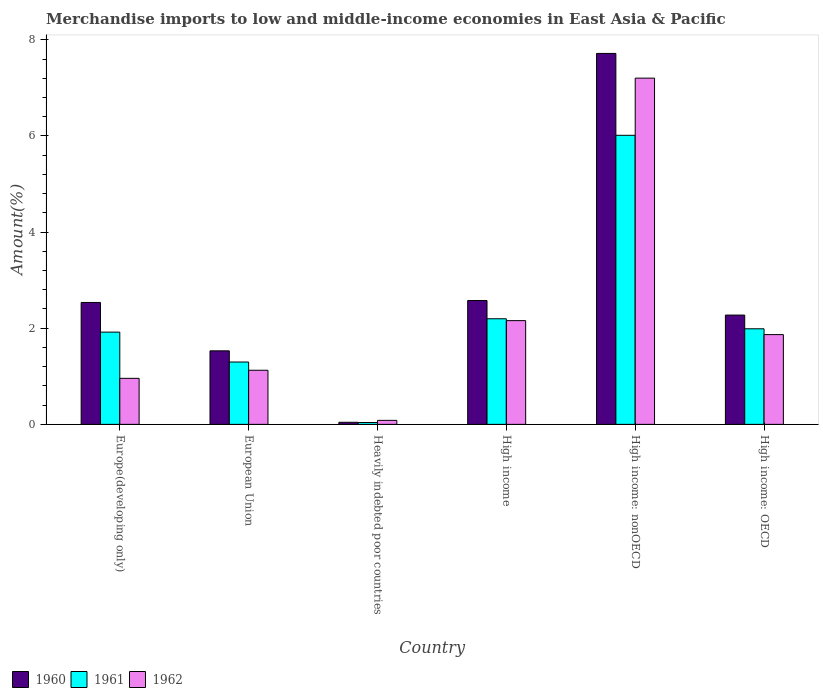How many groups of bars are there?
Keep it short and to the point. 6. Are the number of bars on each tick of the X-axis equal?
Offer a terse response. Yes. How many bars are there on the 6th tick from the right?
Your answer should be compact. 3. What is the label of the 1st group of bars from the left?
Ensure brevity in your answer.  Europe(developing only). In how many cases, is the number of bars for a given country not equal to the number of legend labels?
Your answer should be very brief. 0. What is the percentage of amount earned from merchandise imports in 1961 in Heavily indebted poor countries?
Your answer should be very brief. 0.04. Across all countries, what is the maximum percentage of amount earned from merchandise imports in 1960?
Keep it short and to the point. 7.72. Across all countries, what is the minimum percentage of amount earned from merchandise imports in 1961?
Ensure brevity in your answer.  0.04. In which country was the percentage of amount earned from merchandise imports in 1962 maximum?
Your answer should be compact. High income: nonOECD. In which country was the percentage of amount earned from merchandise imports in 1962 minimum?
Give a very brief answer. Heavily indebted poor countries. What is the total percentage of amount earned from merchandise imports in 1961 in the graph?
Provide a succinct answer. 13.45. What is the difference between the percentage of amount earned from merchandise imports in 1961 in Heavily indebted poor countries and that in High income?
Provide a short and direct response. -2.16. What is the difference between the percentage of amount earned from merchandise imports in 1962 in High income and the percentage of amount earned from merchandise imports in 1961 in High income: OECD?
Make the answer very short. 0.17. What is the average percentage of amount earned from merchandise imports in 1962 per country?
Keep it short and to the point. 2.23. What is the difference between the percentage of amount earned from merchandise imports of/in 1961 and percentage of amount earned from merchandise imports of/in 1960 in European Union?
Provide a short and direct response. -0.23. What is the ratio of the percentage of amount earned from merchandise imports in 1960 in European Union to that in High income: OECD?
Provide a succinct answer. 0.67. What is the difference between the highest and the second highest percentage of amount earned from merchandise imports in 1960?
Your answer should be very brief. 0.04. What is the difference between the highest and the lowest percentage of amount earned from merchandise imports in 1960?
Offer a very short reply. 7.67. Is the sum of the percentage of amount earned from merchandise imports in 1961 in Europe(developing only) and High income: OECD greater than the maximum percentage of amount earned from merchandise imports in 1962 across all countries?
Provide a succinct answer. No. What does the 2nd bar from the left in High income: nonOECD represents?
Give a very brief answer. 1961. What does the 2nd bar from the right in European Union represents?
Provide a short and direct response. 1961. Where does the legend appear in the graph?
Ensure brevity in your answer.  Bottom left. How many legend labels are there?
Provide a short and direct response. 3. What is the title of the graph?
Ensure brevity in your answer.  Merchandise imports to low and middle-income economies in East Asia & Pacific. What is the label or title of the X-axis?
Keep it short and to the point. Country. What is the label or title of the Y-axis?
Offer a very short reply. Amount(%). What is the Amount(%) of 1960 in Europe(developing only)?
Keep it short and to the point. 2.54. What is the Amount(%) of 1961 in Europe(developing only)?
Offer a terse response. 1.92. What is the Amount(%) of 1962 in Europe(developing only)?
Offer a terse response. 0.96. What is the Amount(%) in 1960 in European Union?
Ensure brevity in your answer.  1.53. What is the Amount(%) in 1961 in European Union?
Ensure brevity in your answer.  1.3. What is the Amount(%) of 1962 in European Union?
Make the answer very short. 1.13. What is the Amount(%) in 1960 in Heavily indebted poor countries?
Keep it short and to the point. 0.04. What is the Amount(%) in 1961 in Heavily indebted poor countries?
Provide a succinct answer. 0.04. What is the Amount(%) in 1962 in Heavily indebted poor countries?
Give a very brief answer. 0.08. What is the Amount(%) of 1960 in High income?
Make the answer very short. 2.58. What is the Amount(%) in 1961 in High income?
Give a very brief answer. 2.2. What is the Amount(%) of 1962 in High income?
Offer a terse response. 2.16. What is the Amount(%) of 1960 in High income: nonOECD?
Your response must be concise. 7.72. What is the Amount(%) of 1961 in High income: nonOECD?
Provide a succinct answer. 6.01. What is the Amount(%) of 1962 in High income: nonOECD?
Provide a short and direct response. 7.2. What is the Amount(%) in 1960 in High income: OECD?
Provide a short and direct response. 2.27. What is the Amount(%) in 1961 in High income: OECD?
Provide a succinct answer. 1.99. What is the Amount(%) in 1962 in High income: OECD?
Give a very brief answer. 1.87. Across all countries, what is the maximum Amount(%) in 1960?
Your answer should be very brief. 7.72. Across all countries, what is the maximum Amount(%) of 1961?
Ensure brevity in your answer.  6.01. Across all countries, what is the maximum Amount(%) in 1962?
Your response must be concise. 7.2. Across all countries, what is the minimum Amount(%) of 1960?
Your response must be concise. 0.04. Across all countries, what is the minimum Amount(%) in 1961?
Make the answer very short. 0.04. Across all countries, what is the minimum Amount(%) of 1962?
Offer a very short reply. 0.08. What is the total Amount(%) of 1960 in the graph?
Offer a very short reply. 16.68. What is the total Amount(%) of 1961 in the graph?
Keep it short and to the point. 13.45. What is the total Amount(%) of 1962 in the graph?
Offer a very short reply. 13.39. What is the difference between the Amount(%) in 1960 in Europe(developing only) and that in European Union?
Your answer should be compact. 1.01. What is the difference between the Amount(%) in 1961 in Europe(developing only) and that in European Union?
Give a very brief answer. 0.62. What is the difference between the Amount(%) in 1962 in Europe(developing only) and that in European Union?
Offer a terse response. -0.17. What is the difference between the Amount(%) in 1960 in Europe(developing only) and that in Heavily indebted poor countries?
Offer a very short reply. 2.49. What is the difference between the Amount(%) of 1961 in Europe(developing only) and that in Heavily indebted poor countries?
Provide a short and direct response. 1.88. What is the difference between the Amount(%) of 1962 in Europe(developing only) and that in Heavily indebted poor countries?
Your answer should be compact. 0.87. What is the difference between the Amount(%) in 1960 in Europe(developing only) and that in High income?
Give a very brief answer. -0.04. What is the difference between the Amount(%) of 1961 in Europe(developing only) and that in High income?
Your answer should be compact. -0.28. What is the difference between the Amount(%) in 1962 in Europe(developing only) and that in High income?
Offer a terse response. -1.2. What is the difference between the Amount(%) in 1960 in Europe(developing only) and that in High income: nonOECD?
Provide a short and direct response. -5.18. What is the difference between the Amount(%) in 1961 in Europe(developing only) and that in High income: nonOECD?
Your answer should be very brief. -4.09. What is the difference between the Amount(%) in 1962 in Europe(developing only) and that in High income: nonOECD?
Give a very brief answer. -6.24. What is the difference between the Amount(%) of 1960 in Europe(developing only) and that in High income: OECD?
Your answer should be very brief. 0.26. What is the difference between the Amount(%) in 1961 in Europe(developing only) and that in High income: OECD?
Your response must be concise. -0.07. What is the difference between the Amount(%) in 1962 in Europe(developing only) and that in High income: OECD?
Your answer should be very brief. -0.91. What is the difference between the Amount(%) of 1960 in European Union and that in Heavily indebted poor countries?
Offer a very short reply. 1.49. What is the difference between the Amount(%) of 1961 in European Union and that in Heavily indebted poor countries?
Make the answer very short. 1.26. What is the difference between the Amount(%) of 1962 in European Union and that in Heavily indebted poor countries?
Your response must be concise. 1.04. What is the difference between the Amount(%) of 1960 in European Union and that in High income?
Your response must be concise. -1.05. What is the difference between the Amount(%) of 1961 in European Union and that in High income?
Your answer should be compact. -0.9. What is the difference between the Amount(%) of 1962 in European Union and that in High income?
Keep it short and to the point. -1.03. What is the difference between the Amount(%) of 1960 in European Union and that in High income: nonOECD?
Provide a short and direct response. -6.19. What is the difference between the Amount(%) in 1961 in European Union and that in High income: nonOECD?
Provide a succinct answer. -4.72. What is the difference between the Amount(%) in 1962 in European Union and that in High income: nonOECD?
Your answer should be compact. -6.08. What is the difference between the Amount(%) of 1960 in European Union and that in High income: OECD?
Your answer should be very brief. -0.74. What is the difference between the Amount(%) in 1961 in European Union and that in High income: OECD?
Offer a terse response. -0.69. What is the difference between the Amount(%) of 1962 in European Union and that in High income: OECD?
Offer a terse response. -0.74. What is the difference between the Amount(%) in 1960 in Heavily indebted poor countries and that in High income?
Keep it short and to the point. -2.53. What is the difference between the Amount(%) in 1961 in Heavily indebted poor countries and that in High income?
Offer a terse response. -2.16. What is the difference between the Amount(%) in 1962 in Heavily indebted poor countries and that in High income?
Offer a terse response. -2.07. What is the difference between the Amount(%) of 1960 in Heavily indebted poor countries and that in High income: nonOECD?
Make the answer very short. -7.67. What is the difference between the Amount(%) of 1961 in Heavily indebted poor countries and that in High income: nonOECD?
Your answer should be compact. -5.97. What is the difference between the Amount(%) in 1962 in Heavily indebted poor countries and that in High income: nonOECD?
Provide a succinct answer. -7.12. What is the difference between the Amount(%) of 1960 in Heavily indebted poor countries and that in High income: OECD?
Your response must be concise. -2.23. What is the difference between the Amount(%) of 1961 in Heavily indebted poor countries and that in High income: OECD?
Your answer should be very brief. -1.95. What is the difference between the Amount(%) in 1962 in Heavily indebted poor countries and that in High income: OECD?
Offer a very short reply. -1.78. What is the difference between the Amount(%) in 1960 in High income and that in High income: nonOECD?
Ensure brevity in your answer.  -5.14. What is the difference between the Amount(%) of 1961 in High income and that in High income: nonOECD?
Your answer should be very brief. -3.82. What is the difference between the Amount(%) in 1962 in High income and that in High income: nonOECD?
Provide a succinct answer. -5.04. What is the difference between the Amount(%) in 1960 in High income and that in High income: OECD?
Your response must be concise. 0.3. What is the difference between the Amount(%) of 1961 in High income and that in High income: OECD?
Provide a short and direct response. 0.21. What is the difference between the Amount(%) of 1962 in High income and that in High income: OECD?
Offer a very short reply. 0.29. What is the difference between the Amount(%) of 1960 in High income: nonOECD and that in High income: OECD?
Ensure brevity in your answer.  5.44. What is the difference between the Amount(%) of 1961 in High income: nonOECD and that in High income: OECD?
Keep it short and to the point. 4.02. What is the difference between the Amount(%) of 1962 in High income: nonOECD and that in High income: OECD?
Keep it short and to the point. 5.33. What is the difference between the Amount(%) of 1960 in Europe(developing only) and the Amount(%) of 1961 in European Union?
Your response must be concise. 1.24. What is the difference between the Amount(%) of 1960 in Europe(developing only) and the Amount(%) of 1962 in European Union?
Offer a terse response. 1.41. What is the difference between the Amount(%) in 1961 in Europe(developing only) and the Amount(%) in 1962 in European Union?
Make the answer very short. 0.79. What is the difference between the Amount(%) in 1960 in Europe(developing only) and the Amount(%) in 1961 in Heavily indebted poor countries?
Keep it short and to the point. 2.5. What is the difference between the Amount(%) of 1960 in Europe(developing only) and the Amount(%) of 1962 in Heavily indebted poor countries?
Ensure brevity in your answer.  2.45. What is the difference between the Amount(%) in 1961 in Europe(developing only) and the Amount(%) in 1962 in Heavily indebted poor countries?
Your answer should be very brief. 1.84. What is the difference between the Amount(%) of 1960 in Europe(developing only) and the Amount(%) of 1961 in High income?
Your response must be concise. 0.34. What is the difference between the Amount(%) in 1960 in Europe(developing only) and the Amount(%) in 1962 in High income?
Your answer should be very brief. 0.38. What is the difference between the Amount(%) of 1961 in Europe(developing only) and the Amount(%) of 1962 in High income?
Offer a very short reply. -0.24. What is the difference between the Amount(%) in 1960 in Europe(developing only) and the Amount(%) in 1961 in High income: nonOECD?
Your answer should be compact. -3.48. What is the difference between the Amount(%) of 1960 in Europe(developing only) and the Amount(%) of 1962 in High income: nonOECD?
Your response must be concise. -4.67. What is the difference between the Amount(%) in 1961 in Europe(developing only) and the Amount(%) in 1962 in High income: nonOECD?
Provide a succinct answer. -5.28. What is the difference between the Amount(%) of 1960 in Europe(developing only) and the Amount(%) of 1961 in High income: OECD?
Offer a very short reply. 0.55. What is the difference between the Amount(%) in 1960 in Europe(developing only) and the Amount(%) in 1962 in High income: OECD?
Your answer should be compact. 0.67. What is the difference between the Amount(%) of 1961 in Europe(developing only) and the Amount(%) of 1962 in High income: OECD?
Provide a succinct answer. 0.05. What is the difference between the Amount(%) in 1960 in European Union and the Amount(%) in 1961 in Heavily indebted poor countries?
Keep it short and to the point. 1.49. What is the difference between the Amount(%) in 1960 in European Union and the Amount(%) in 1962 in Heavily indebted poor countries?
Offer a terse response. 1.45. What is the difference between the Amount(%) in 1961 in European Union and the Amount(%) in 1962 in Heavily indebted poor countries?
Make the answer very short. 1.21. What is the difference between the Amount(%) of 1960 in European Union and the Amount(%) of 1961 in High income?
Keep it short and to the point. -0.67. What is the difference between the Amount(%) in 1960 in European Union and the Amount(%) in 1962 in High income?
Your response must be concise. -0.63. What is the difference between the Amount(%) in 1961 in European Union and the Amount(%) in 1962 in High income?
Make the answer very short. -0.86. What is the difference between the Amount(%) in 1960 in European Union and the Amount(%) in 1961 in High income: nonOECD?
Your answer should be compact. -4.48. What is the difference between the Amount(%) in 1960 in European Union and the Amount(%) in 1962 in High income: nonOECD?
Ensure brevity in your answer.  -5.67. What is the difference between the Amount(%) in 1961 in European Union and the Amount(%) in 1962 in High income: nonOECD?
Your response must be concise. -5.91. What is the difference between the Amount(%) of 1960 in European Union and the Amount(%) of 1961 in High income: OECD?
Your response must be concise. -0.46. What is the difference between the Amount(%) of 1960 in European Union and the Amount(%) of 1962 in High income: OECD?
Your response must be concise. -0.34. What is the difference between the Amount(%) in 1961 in European Union and the Amount(%) in 1962 in High income: OECD?
Your answer should be compact. -0.57. What is the difference between the Amount(%) of 1960 in Heavily indebted poor countries and the Amount(%) of 1961 in High income?
Provide a short and direct response. -2.15. What is the difference between the Amount(%) in 1960 in Heavily indebted poor countries and the Amount(%) in 1962 in High income?
Make the answer very short. -2.11. What is the difference between the Amount(%) in 1961 in Heavily indebted poor countries and the Amount(%) in 1962 in High income?
Make the answer very short. -2.12. What is the difference between the Amount(%) in 1960 in Heavily indebted poor countries and the Amount(%) in 1961 in High income: nonOECD?
Keep it short and to the point. -5.97. What is the difference between the Amount(%) of 1960 in Heavily indebted poor countries and the Amount(%) of 1962 in High income: nonOECD?
Your answer should be compact. -7.16. What is the difference between the Amount(%) of 1961 in Heavily indebted poor countries and the Amount(%) of 1962 in High income: nonOECD?
Your answer should be very brief. -7.16. What is the difference between the Amount(%) of 1960 in Heavily indebted poor countries and the Amount(%) of 1961 in High income: OECD?
Offer a terse response. -1.95. What is the difference between the Amount(%) in 1960 in Heavily indebted poor countries and the Amount(%) in 1962 in High income: OECD?
Your response must be concise. -1.82. What is the difference between the Amount(%) in 1961 in Heavily indebted poor countries and the Amount(%) in 1962 in High income: OECD?
Provide a short and direct response. -1.83. What is the difference between the Amount(%) of 1960 in High income and the Amount(%) of 1961 in High income: nonOECD?
Your answer should be very brief. -3.44. What is the difference between the Amount(%) of 1960 in High income and the Amount(%) of 1962 in High income: nonOECD?
Offer a terse response. -4.63. What is the difference between the Amount(%) in 1961 in High income and the Amount(%) in 1962 in High income: nonOECD?
Your response must be concise. -5.01. What is the difference between the Amount(%) in 1960 in High income and the Amount(%) in 1961 in High income: OECD?
Your answer should be compact. 0.59. What is the difference between the Amount(%) of 1960 in High income and the Amount(%) of 1962 in High income: OECD?
Give a very brief answer. 0.71. What is the difference between the Amount(%) in 1961 in High income and the Amount(%) in 1962 in High income: OECD?
Your answer should be compact. 0.33. What is the difference between the Amount(%) in 1960 in High income: nonOECD and the Amount(%) in 1961 in High income: OECD?
Provide a short and direct response. 5.73. What is the difference between the Amount(%) of 1960 in High income: nonOECD and the Amount(%) of 1962 in High income: OECD?
Provide a succinct answer. 5.85. What is the difference between the Amount(%) of 1961 in High income: nonOECD and the Amount(%) of 1962 in High income: OECD?
Make the answer very short. 4.15. What is the average Amount(%) of 1960 per country?
Your answer should be very brief. 2.78. What is the average Amount(%) of 1961 per country?
Make the answer very short. 2.24. What is the average Amount(%) in 1962 per country?
Make the answer very short. 2.23. What is the difference between the Amount(%) of 1960 and Amount(%) of 1961 in Europe(developing only)?
Provide a short and direct response. 0.62. What is the difference between the Amount(%) in 1960 and Amount(%) in 1962 in Europe(developing only)?
Give a very brief answer. 1.58. What is the difference between the Amount(%) of 1961 and Amount(%) of 1962 in Europe(developing only)?
Your answer should be very brief. 0.96. What is the difference between the Amount(%) of 1960 and Amount(%) of 1961 in European Union?
Your response must be concise. 0.23. What is the difference between the Amount(%) in 1960 and Amount(%) in 1962 in European Union?
Your answer should be very brief. 0.4. What is the difference between the Amount(%) of 1961 and Amount(%) of 1962 in European Union?
Provide a short and direct response. 0.17. What is the difference between the Amount(%) of 1960 and Amount(%) of 1961 in Heavily indebted poor countries?
Offer a terse response. 0. What is the difference between the Amount(%) in 1960 and Amount(%) in 1962 in Heavily indebted poor countries?
Your answer should be very brief. -0.04. What is the difference between the Amount(%) in 1961 and Amount(%) in 1962 in Heavily indebted poor countries?
Give a very brief answer. -0.04. What is the difference between the Amount(%) of 1960 and Amount(%) of 1961 in High income?
Your answer should be very brief. 0.38. What is the difference between the Amount(%) in 1960 and Amount(%) in 1962 in High income?
Give a very brief answer. 0.42. What is the difference between the Amount(%) of 1961 and Amount(%) of 1962 in High income?
Your response must be concise. 0.04. What is the difference between the Amount(%) of 1960 and Amount(%) of 1961 in High income: nonOECD?
Give a very brief answer. 1.7. What is the difference between the Amount(%) of 1960 and Amount(%) of 1962 in High income: nonOECD?
Provide a succinct answer. 0.51. What is the difference between the Amount(%) of 1961 and Amount(%) of 1962 in High income: nonOECD?
Give a very brief answer. -1.19. What is the difference between the Amount(%) in 1960 and Amount(%) in 1961 in High income: OECD?
Offer a very short reply. 0.29. What is the difference between the Amount(%) in 1960 and Amount(%) in 1962 in High income: OECD?
Your answer should be compact. 0.41. What is the difference between the Amount(%) of 1961 and Amount(%) of 1962 in High income: OECD?
Provide a succinct answer. 0.12. What is the ratio of the Amount(%) in 1960 in Europe(developing only) to that in European Union?
Offer a very short reply. 1.66. What is the ratio of the Amount(%) in 1961 in Europe(developing only) to that in European Union?
Provide a short and direct response. 1.48. What is the ratio of the Amount(%) in 1962 in Europe(developing only) to that in European Union?
Keep it short and to the point. 0.85. What is the ratio of the Amount(%) of 1960 in Europe(developing only) to that in Heavily indebted poor countries?
Keep it short and to the point. 58.4. What is the ratio of the Amount(%) in 1961 in Europe(developing only) to that in Heavily indebted poor countries?
Give a very brief answer. 49.7. What is the ratio of the Amount(%) of 1962 in Europe(developing only) to that in Heavily indebted poor countries?
Your answer should be very brief. 11.5. What is the ratio of the Amount(%) of 1960 in Europe(developing only) to that in High income?
Make the answer very short. 0.98. What is the ratio of the Amount(%) of 1961 in Europe(developing only) to that in High income?
Give a very brief answer. 0.87. What is the ratio of the Amount(%) in 1962 in Europe(developing only) to that in High income?
Keep it short and to the point. 0.44. What is the ratio of the Amount(%) of 1960 in Europe(developing only) to that in High income: nonOECD?
Provide a short and direct response. 0.33. What is the ratio of the Amount(%) of 1961 in Europe(developing only) to that in High income: nonOECD?
Keep it short and to the point. 0.32. What is the ratio of the Amount(%) of 1962 in Europe(developing only) to that in High income: nonOECD?
Provide a short and direct response. 0.13. What is the ratio of the Amount(%) in 1960 in Europe(developing only) to that in High income: OECD?
Offer a terse response. 1.12. What is the ratio of the Amount(%) of 1961 in Europe(developing only) to that in High income: OECD?
Provide a succinct answer. 0.97. What is the ratio of the Amount(%) of 1962 in Europe(developing only) to that in High income: OECD?
Offer a terse response. 0.51. What is the ratio of the Amount(%) of 1960 in European Union to that in Heavily indebted poor countries?
Keep it short and to the point. 35.23. What is the ratio of the Amount(%) of 1961 in European Union to that in Heavily indebted poor countries?
Your answer should be very brief. 33.59. What is the ratio of the Amount(%) in 1962 in European Union to that in Heavily indebted poor countries?
Your answer should be very brief. 13.51. What is the ratio of the Amount(%) in 1960 in European Union to that in High income?
Make the answer very short. 0.59. What is the ratio of the Amount(%) of 1961 in European Union to that in High income?
Your answer should be compact. 0.59. What is the ratio of the Amount(%) in 1962 in European Union to that in High income?
Give a very brief answer. 0.52. What is the ratio of the Amount(%) of 1960 in European Union to that in High income: nonOECD?
Ensure brevity in your answer.  0.2. What is the ratio of the Amount(%) of 1961 in European Union to that in High income: nonOECD?
Give a very brief answer. 0.22. What is the ratio of the Amount(%) of 1962 in European Union to that in High income: nonOECD?
Provide a short and direct response. 0.16. What is the ratio of the Amount(%) in 1960 in European Union to that in High income: OECD?
Provide a succinct answer. 0.67. What is the ratio of the Amount(%) in 1961 in European Union to that in High income: OECD?
Your answer should be very brief. 0.65. What is the ratio of the Amount(%) of 1962 in European Union to that in High income: OECD?
Provide a succinct answer. 0.6. What is the ratio of the Amount(%) in 1960 in Heavily indebted poor countries to that in High income?
Make the answer very short. 0.02. What is the ratio of the Amount(%) in 1961 in Heavily indebted poor countries to that in High income?
Your answer should be very brief. 0.02. What is the ratio of the Amount(%) of 1962 in Heavily indebted poor countries to that in High income?
Your response must be concise. 0.04. What is the ratio of the Amount(%) in 1960 in Heavily indebted poor countries to that in High income: nonOECD?
Ensure brevity in your answer.  0.01. What is the ratio of the Amount(%) of 1961 in Heavily indebted poor countries to that in High income: nonOECD?
Keep it short and to the point. 0.01. What is the ratio of the Amount(%) of 1962 in Heavily indebted poor countries to that in High income: nonOECD?
Provide a succinct answer. 0.01. What is the ratio of the Amount(%) of 1960 in Heavily indebted poor countries to that in High income: OECD?
Offer a very short reply. 0.02. What is the ratio of the Amount(%) in 1961 in Heavily indebted poor countries to that in High income: OECD?
Ensure brevity in your answer.  0.02. What is the ratio of the Amount(%) of 1962 in Heavily indebted poor countries to that in High income: OECD?
Provide a short and direct response. 0.04. What is the ratio of the Amount(%) in 1960 in High income to that in High income: nonOECD?
Make the answer very short. 0.33. What is the ratio of the Amount(%) in 1961 in High income to that in High income: nonOECD?
Offer a terse response. 0.37. What is the ratio of the Amount(%) of 1962 in High income to that in High income: nonOECD?
Provide a short and direct response. 0.3. What is the ratio of the Amount(%) of 1960 in High income to that in High income: OECD?
Your response must be concise. 1.13. What is the ratio of the Amount(%) of 1961 in High income to that in High income: OECD?
Keep it short and to the point. 1.1. What is the ratio of the Amount(%) of 1962 in High income to that in High income: OECD?
Keep it short and to the point. 1.16. What is the ratio of the Amount(%) of 1960 in High income: nonOECD to that in High income: OECD?
Keep it short and to the point. 3.39. What is the ratio of the Amount(%) in 1961 in High income: nonOECD to that in High income: OECD?
Keep it short and to the point. 3.02. What is the ratio of the Amount(%) of 1962 in High income: nonOECD to that in High income: OECD?
Offer a very short reply. 3.86. What is the difference between the highest and the second highest Amount(%) in 1960?
Your answer should be compact. 5.14. What is the difference between the highest and the second highest Amount(%) of 1961?
Your response must be concise. 3.82. What is the difference between the highest and the second highest Amount(%) of 1962?
Give a very brief answer. 5.04. What is the difference between the highest and the lowest Amount(%) in 1960?
Your answer should be compact. 7.67. What is the difference between the highest and the lowest Amount(%) in 1961?
Provide a short and direct response. 5.97. What is the difference between the highest and the lowest Amount(%) of 1962?
Your response must be concise. 7.12. 